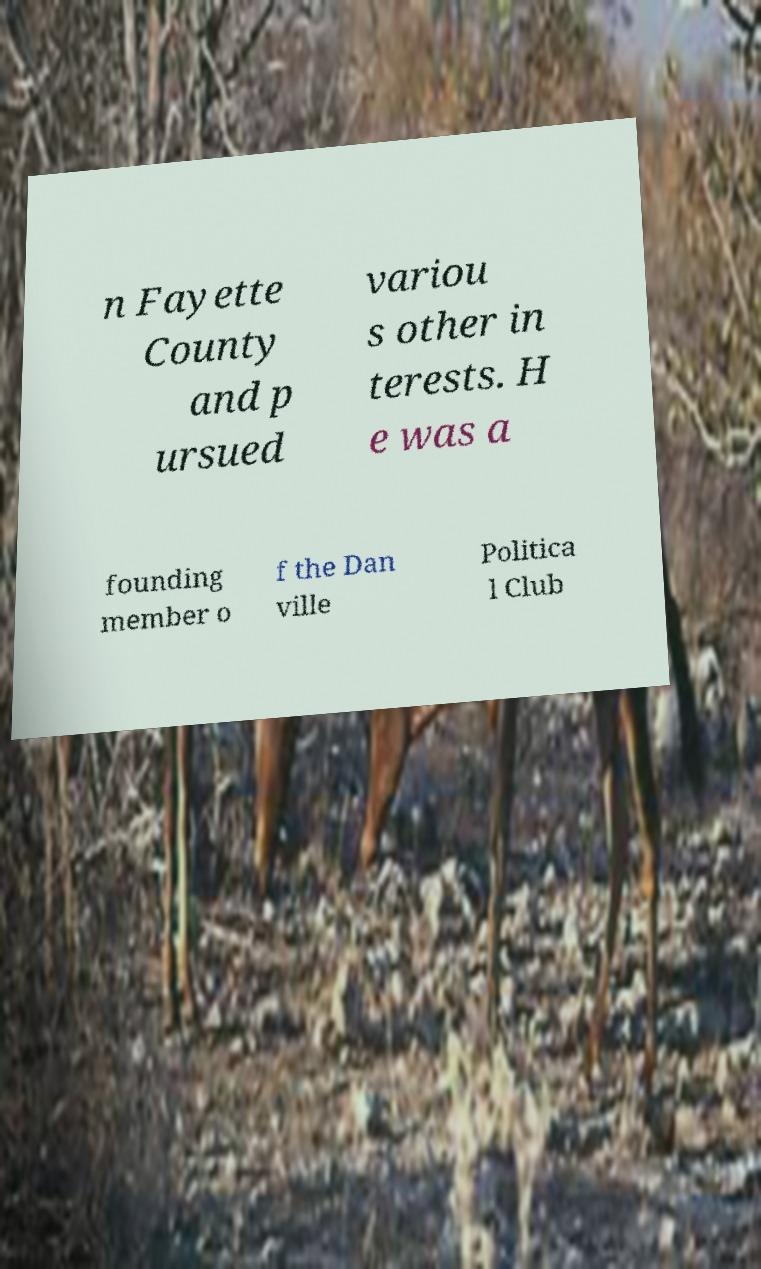Could you assist in decoding the text presented in this image and type it out clearly? n Fayette County and p ursued variou s other in terests. H e was a founding member o f the Dan ville Politica l Club 